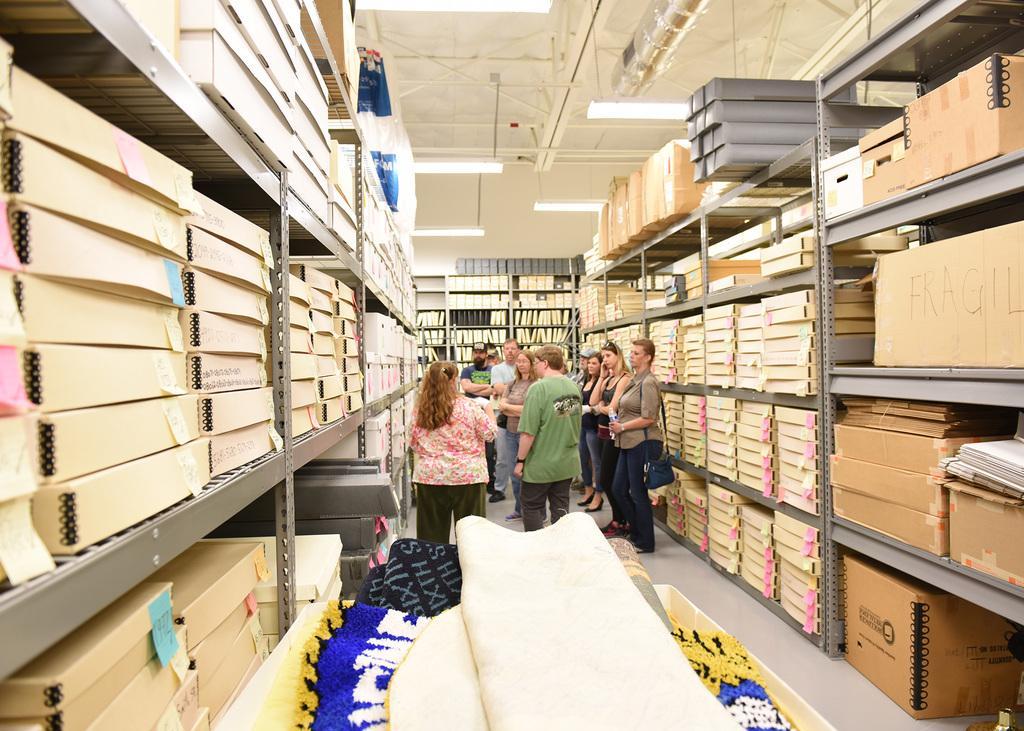Please provide a concise description of this image. In this picture we can see colorful mats at the bottom of the picture. There are a few boxes, colorful papers and other objects visible in the racks. We can see a few rods and tube lights on top. 